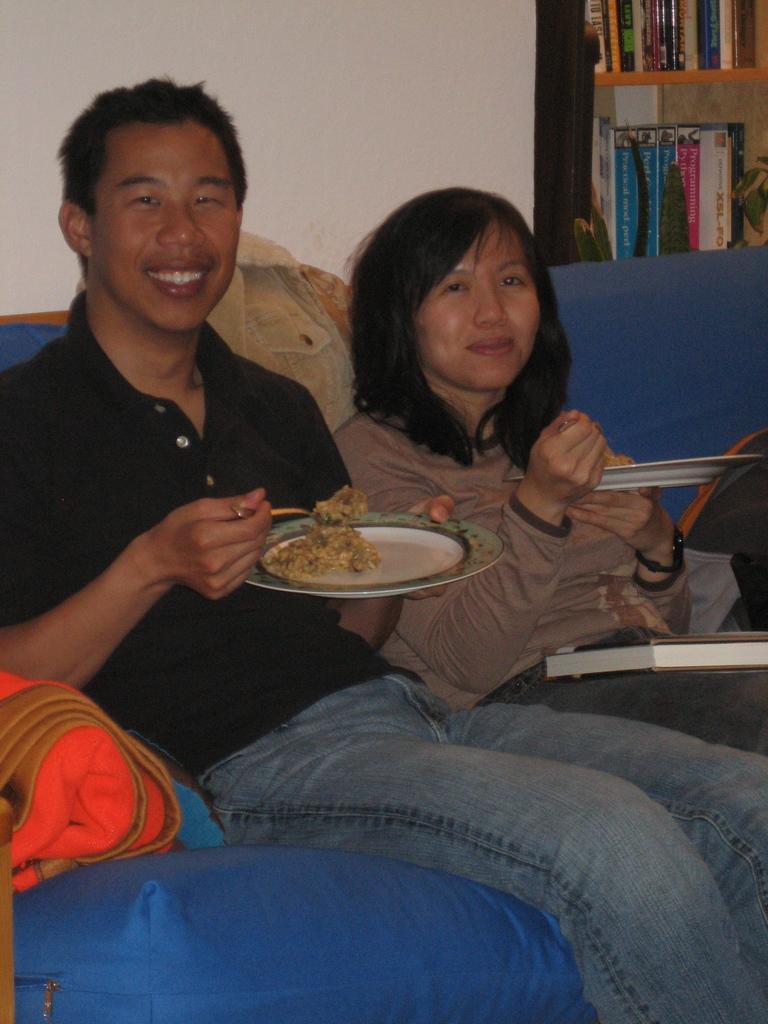How would you summarize this image in a sentence or two? In this picture there are two people sitting on sofa and smiling and holding plates with food. We can see clothes and book. In the background of the image we can see wall, books in racks and leaves. 